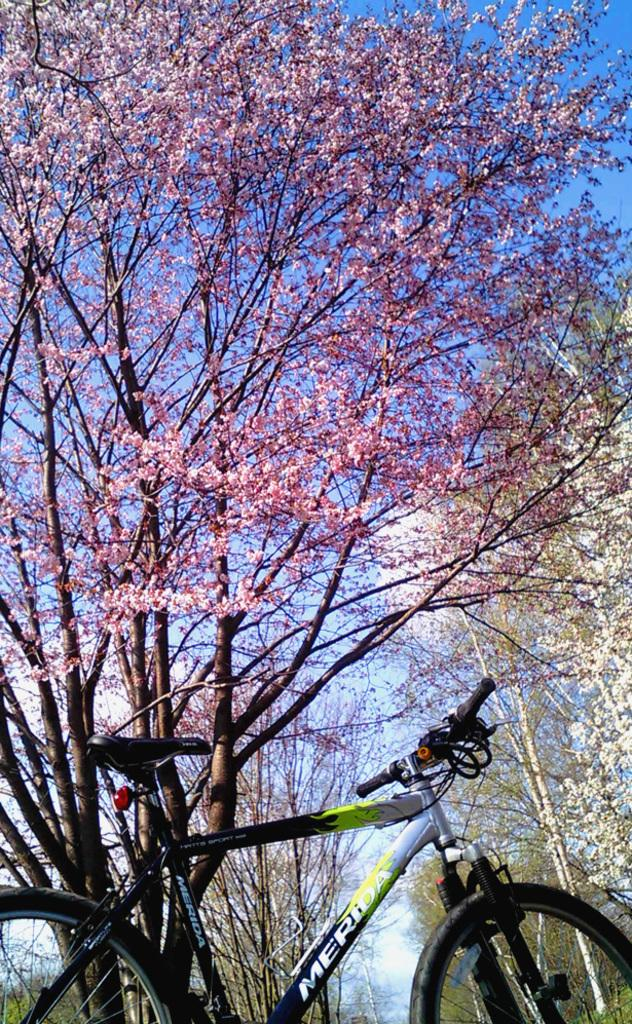What is the main object in the picture? There is a bicycle in the picture. What can be seen in the background of the picture? Trees are visible in the picture. What is visible in the sky in the picture? Clouds are present in the sky in the picture. What type of bait is being used by the tree in the picture? There is no bait present in the image, and trees do not use bait. 